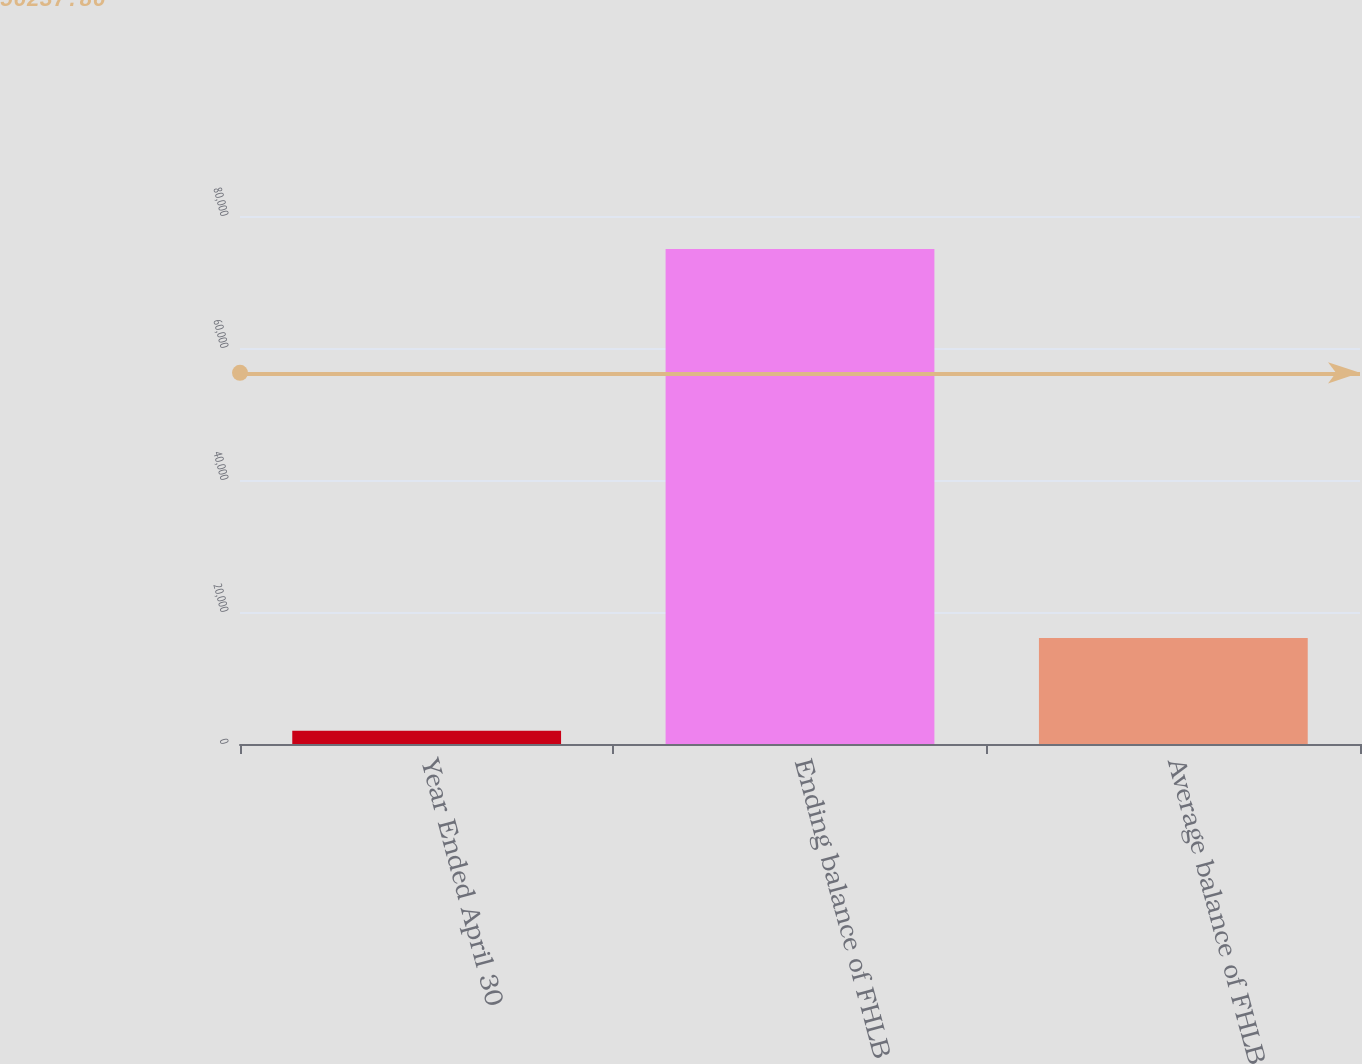<chart> <loc_0><loc_0><loc_500><loc_500><bar_chart><fcel>Year Ended April 30<fcel>Ending balance of FHLB<fcel>Average balance of FHLB<nl><fcel>2007<fcel>75000<fcel>16055<nl></chart> 